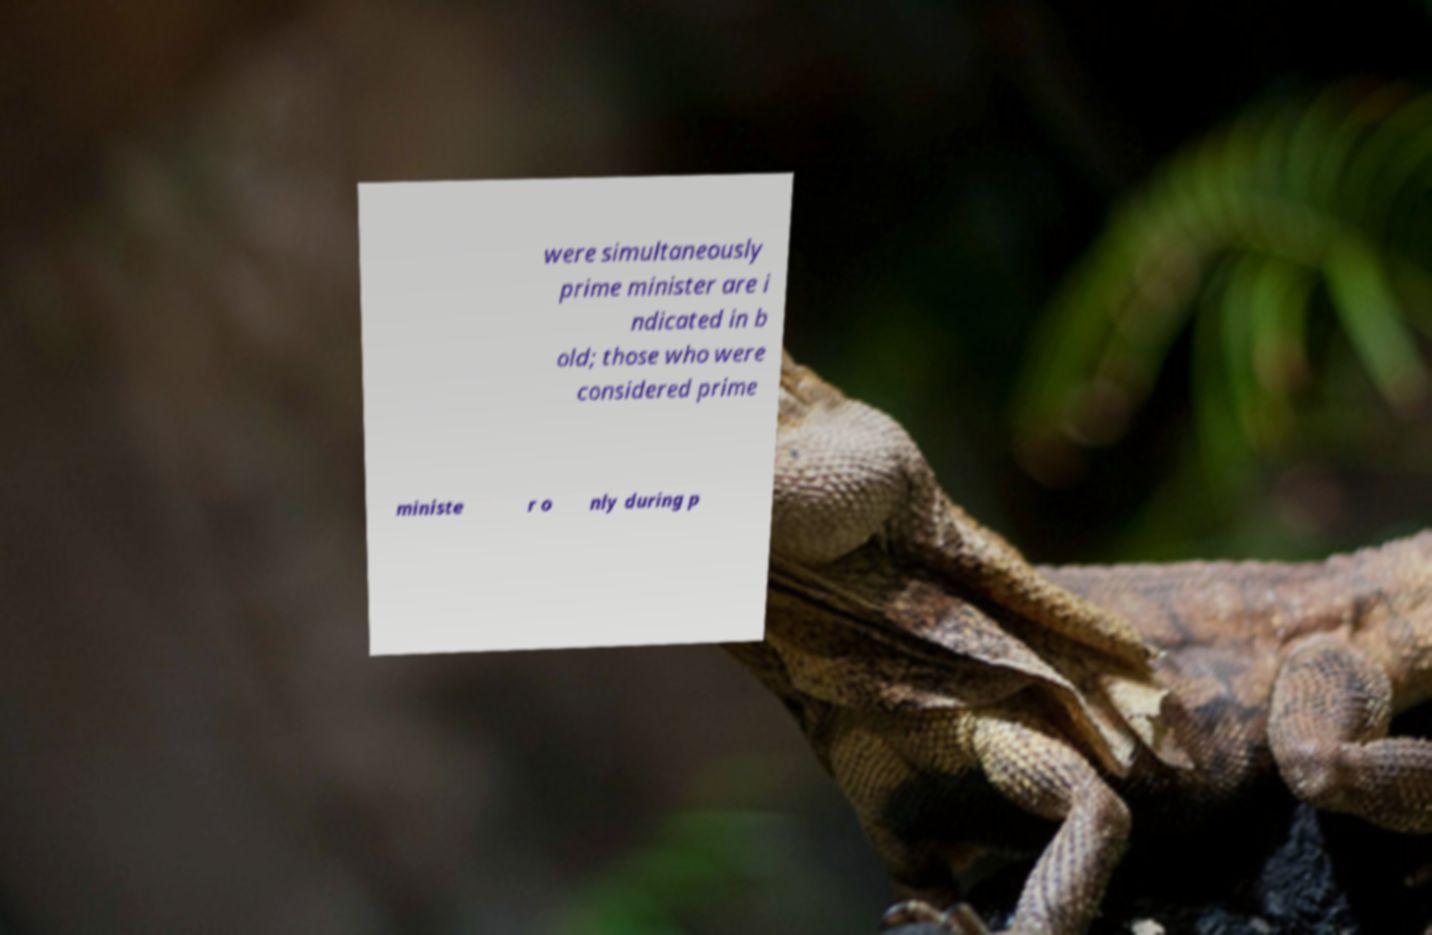Could you extract and type out the text from this image? were simultaneously prime minister are i ndicated in b old; those who were considered prime ministe r o nly during p 